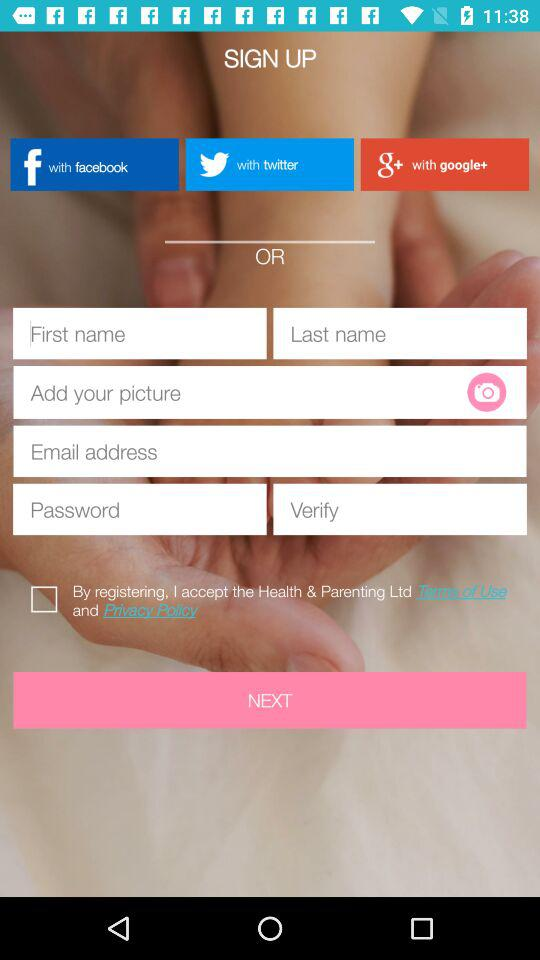Is "By registering, I accept the Health & Parenting Ltd" checked or unchecked? "By registering, I accept the Health & Parenting Ltd" is "unchecked". 